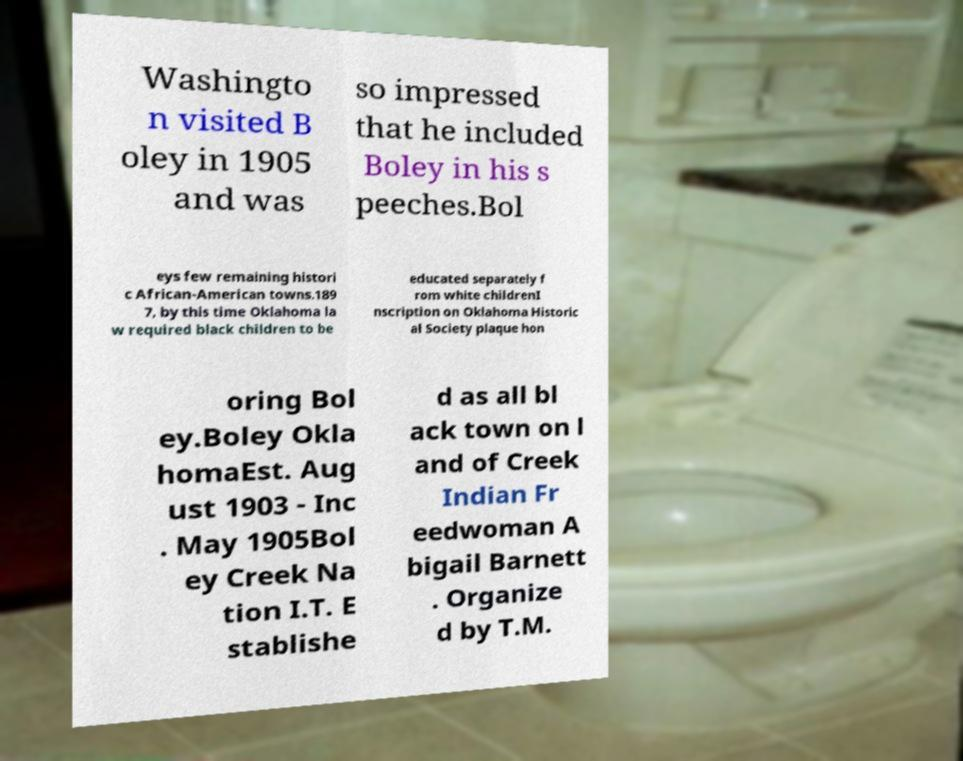There's text embedded in this image that I need extracted. Can you transcribe it verbatim? Washingto n visited B oley in 1905 and was so impressed that he included Boley in his s peeches.Bol eys few remaining histori c African-American towns.189 7, by this time Oklahoma la w required black children to be educated separately f rom white childrenI nscription on Oklahoma Historic al Society plaque hon oring Bol ey.Boley Okla homaEst. Aug ust 1903 - Inc . May 1905Bol ey Creek Na tion I.T. E stablishe d as all bl ack town on l and of Creek Indian Fr eedwoman A bigail Barnett . Organize d by T.M. 